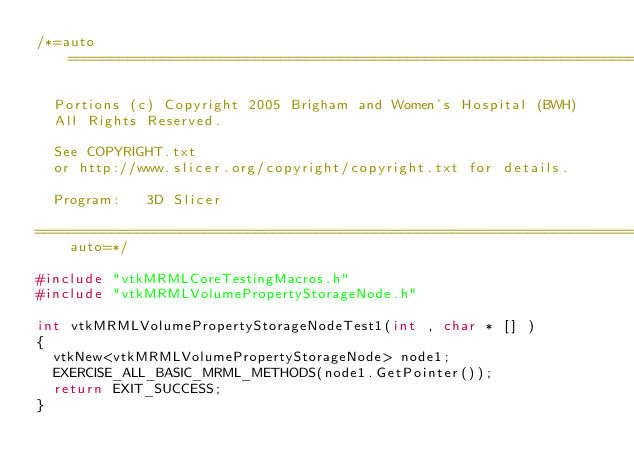Convert code to text. <code><loc_0><loc_0><loc_500><loc_500><_C++_>/*=auto=========================================================================

  Portions (c) Copyright 2005 Brigham and Women's Hospital (BWH)
  All Rights Reserved.

  See COPYRIGHT.txt
  or http://www.slicer.org/copyright/copyright.txt for details.

  Program:   3D Slicer

=========================================================================auto=*/

#include "vtkMRMLCoreTestingMacros.h"
#include "vtkMRMLVolumePropertyStorageNode.h"

int vtkMRMLVolumePropertyStorageNodeTest1(int , char * [] )
{
  vtkNew<vtkMRMLVolumePropertyStorageNode> node1;
  EXERCISE_ALL_BASIC_MRML_METHODS(node1.GetPointer());
  return EXIT_SUCCESS;
}
</code> 